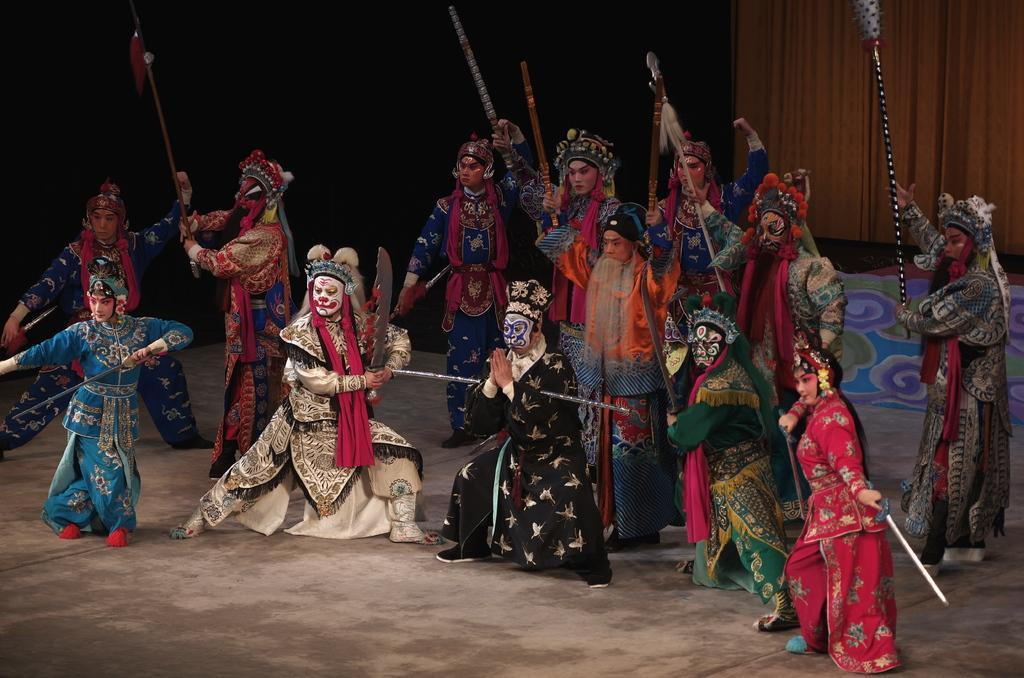How would you summarize this image in a sentence or two? In the image we can see there are people wearing different costumes and shoes and it looks like they are dancing, some of them are holding objects in their hands. Here we can see a floor, curtains and the background is dark. 